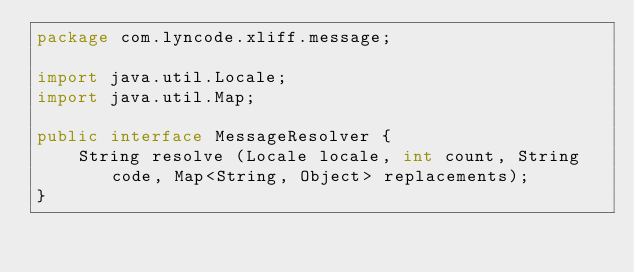Convert code to text. <code><loc_0><loc_0><loc_500><loc_500><_Java_>package com.lyncode.xliff.message;

import java.util.Locale;
import java.util.Map;

public interface MessageResolver {
    String resolve (Locale locale, int count, String code, Map<String, Object> replacements);
}
</code> 